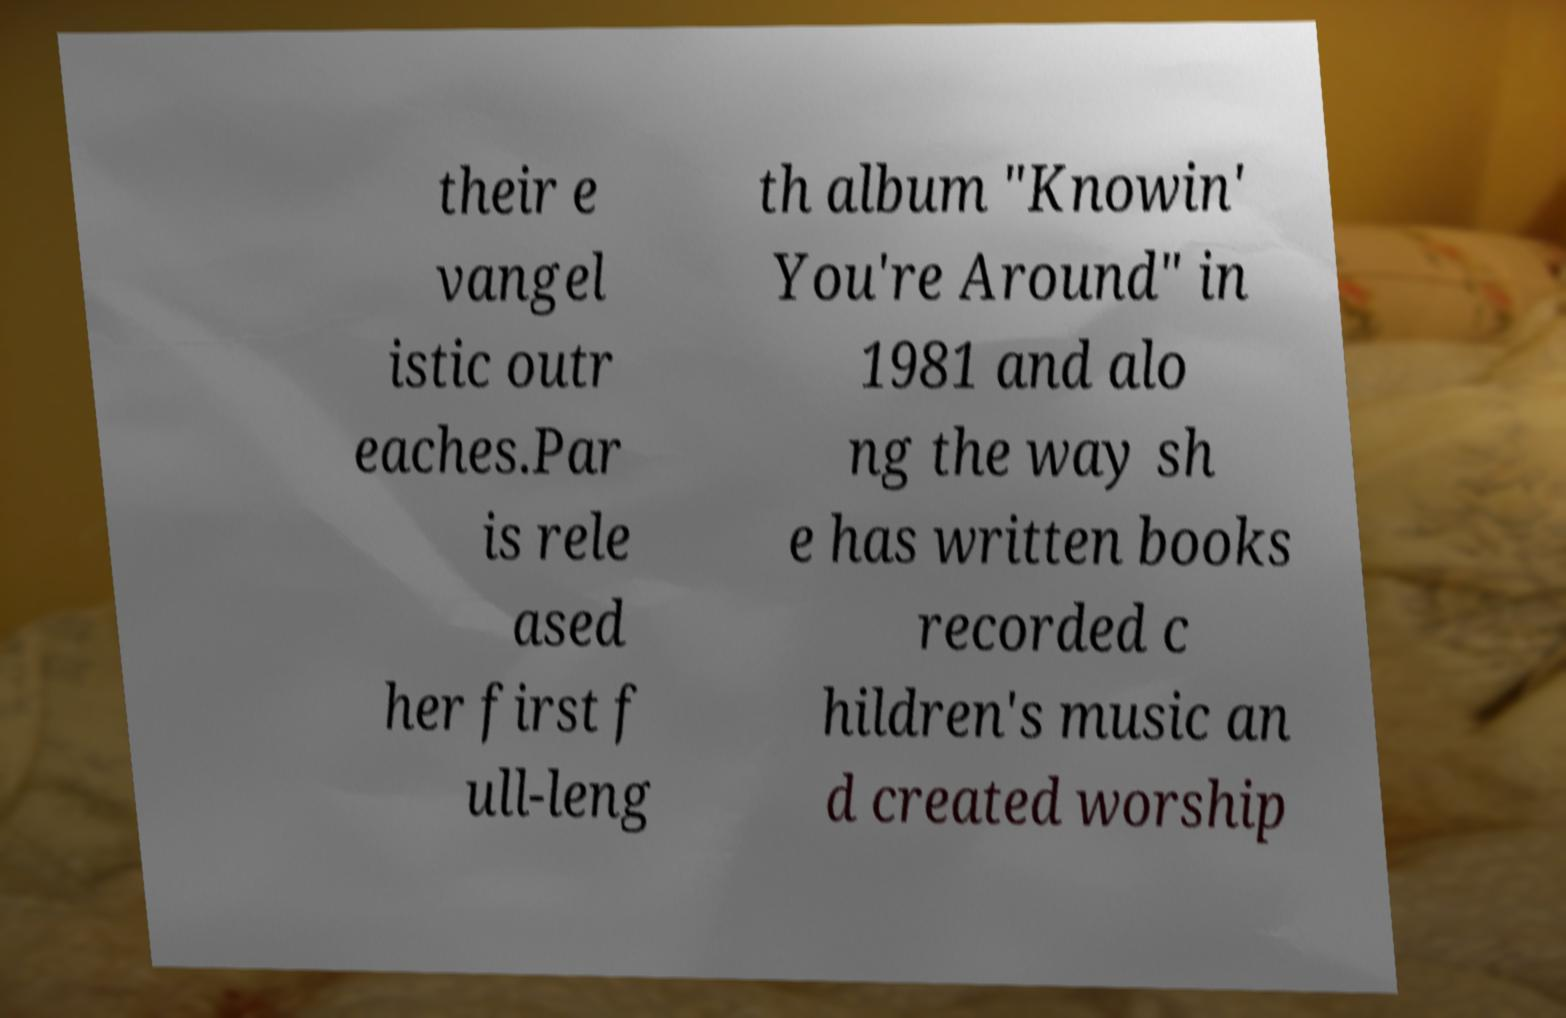I need the written content from this picture converted into text. Can you do that? their e vangel istic outr eaches.Par is rele ased her first f ull-leng th album "Knowin' You're Around" in 1981 and alo ng the way sh e has written books recorded c hildren's music an d created worship 